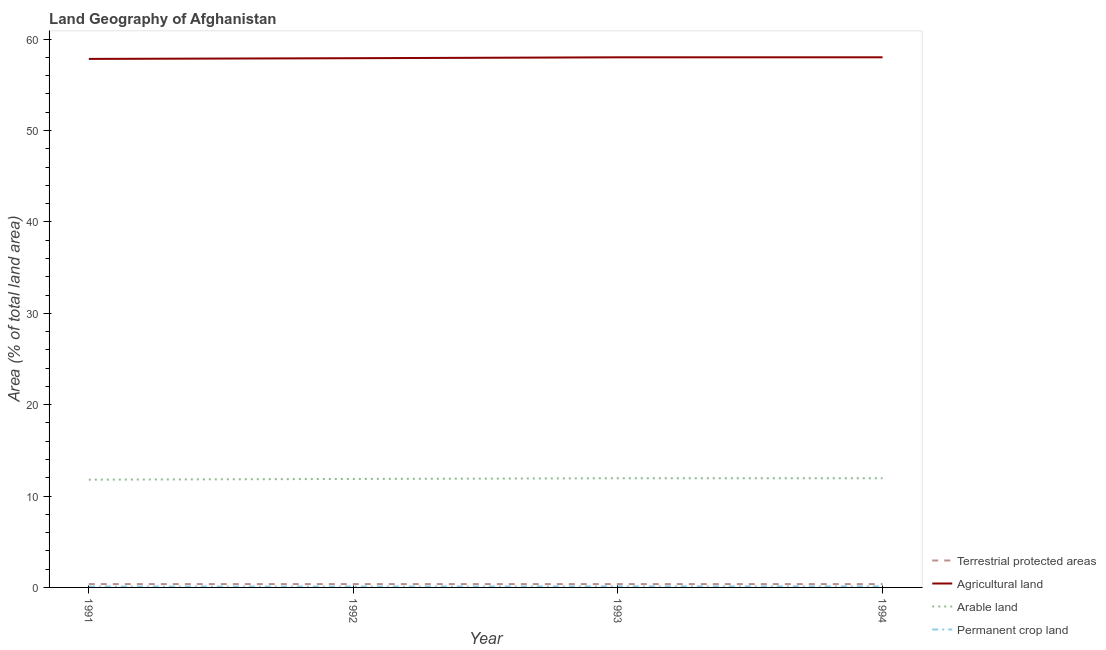How many different coloured lines are there?
Give a very brief answer. 4. Is the number of lines equal to the number of legend labels?
Offer a very short reply. Yes. What is the percentage of area under arable land in 1993?
Your answer should be compact. 11.95. Across all years, what is the maximum percentage of land under terrestrial protection?
Your response must be concise. 0.37. Across all years, what is the minimum percentage of area under arable land?
Offer a very short reply. 11.79. In which year was the percentage of area under permanent crop land minimum?
Provide a short and direct response. 1991. What is the total percentage of land under terrestrial protection in the graph?
Your response must be concise. 1.47. What is the difference between the percentage of land under terrestrial protection in 1993 and that in 1994?
Provide a short and direct response. 0. What is the difference between the percentage of area under arable land in 1992 and the percentage of area under agricultural land in 1993?
Keep it short and to the point. -46.14. What is the average percentage of land under terrestrial protection per year?
Offer a terse response. 0.37. In the year 1994, what is the difference between the percentage of area under arable land and percentage of area under permanent crop land?
Your response must be concise. 11.83. In how many years, is the percentage of area under permanent crop land greater than 50 %?
Make the answer very short. 0. What is the ratio of the percentage of area under arable land in 1992 to that in 1993?
Offer a terse response. 0.99. Is the difference between the percentage of area under agricultural land in 1992 and 1994 greater than the difference between the percentage of land under terrestrial protection in 1992 and 1994?
Give a very brief answer. No. What is the difference between the highest and the second highest percentage of area under arable land?
Your response must be concise. 0. What is the difference between the highest and the lowest percentage of area under agricultural land?
Give a very brief answer. 0.18. In how many years, is the percentage of area under agricultural land greater than the average percentage of area under agricultural land taken over all years?
Ensure brevity in your answer.  2. Is it the case that in every year, the sum of the percentage of land under terrestrial protection and percentage of area under agricultural land is greater than the percentage of area under arable land?
Provide a succinct answer. Yes. How many years are there in the graph?
Your response must be concise. 4. What is the difference between two consecutive major ticks on the Y-axis?
Ensure brevity in your answer.  10. Are the values on the major ticks of Y-axis written in scientific E-notation?
Ensure brevity in your answer.  No. Does the graph contain any zero values?
Provide a short and direct response. No. Does the graph contain grids?
Offer a very short reply. No. Where does the legend appear in the graph?
Your answer should be very brief. Bottom right. How many legend labels are there?
Keep it short and to the point. 4. What is the title of the graph?
Your response must be concise. Land Geography of Afghanistan. What is the label or title of the X-axis?
Keep it short and to the point. Year. What is the label or title of the Y-axis?
Keep it short and to the point. Area (% of total land area). What is the Area (% of total land area) in Terrestrial protected areas in 1991?
Provide a short and direct response. 0.37. What is the Area (% of total land area) in Agricultural land in 1991?
Your answer should be compact. 57.84. What is the Area (% of total land area) of Arable land in 1991?
Your response must be concise. 11.79. What is the Area (% of total land area) in Permanent crop land in 1991?
Make the answer very short. 0.09. What is the Area (% of total land area) of Terrestrial protected areas in 1992?
Provide a short and direct response. 0.37. What is the Area (% of total land area) in Agricultural land in 1992?
Provide a succinct answer. 57.91. What is the Area (% of total land area) of Arable land in 1992?
Ensure brevity in your answer.  11.87. What is the Area (% of total land area) in Permanent crop land in 1992?
Offer a terse response. 0.09. What is the Area (% of total land area) of Terrestrial protected areas in 1993?
Ensure brevity in your answer.  0.37. What is the Area (% of total land area) of Agricultural land in 1993?
Make the answer very short. 58.01. What is the Area (% of total land area) of Arable land in 1993?
Offer a terse response. 11.95. What is the Area (% of total land area) of Permanent crop land in 1993?
Your answer should be compact. 0.11. What is the Area (% of total land area) of Terrestrial protected areas in 1994?
Offer a terse response. 0.37. What is the Area (% of total land area) of Agricultural land in 1994?
Your answer should be compact. 58.01. What is the Area (% of total land area) in Arable land in 1994?
Give a very brief answer. 11.95. What is the Area (% of total land area) in Permanent crop land in 1994?
Keep it short and to the point. 0.11. Across all years, what is the maximum Area (% of total land area) of Terrestrial protected areas?
Offer a very short reply. 0.37. Across all years, what is the maximum Area (% of total land area) in Agricultural land?
Offer a very short reply. 58.01. Across all years, what is the maximum Area (% of total land area) in Arable land?
Offer a terse response. 11.95. Across all years, what is the maximum Area (% of total land area) in Permanent crop land?
Offer a terse response. 0.11. Across all years, what is the minimum Area (% of total land area) in Terrestrial protected areas?
Ensure brevity in your answer.  0.37. Across all years, what is the minimum Area (% of total land area) in Agricultural land?
Offer a terse response. 57.84. Across all years, what is the minimum Area (% of total land area) in Arable land?
Ensure brevity in your answer.  11.79. Across all years, what is the minimum Area (% of total land area) in Permanent crop land?
Offer a terse response. 0.09. What is the total Area (% of total land area) of Terrestrial protected areas in the graph?
Provide a succinct answer. 1.47. What is the total Area (% of total land area) of Agricultural land in the graph?
Keep it short and to the point. 231.78. What is the total Area (% of total land area) in Arable land in the graph?
Your answer should be very brief. 47.56. What is the total Area (% of total land area) of Permanent crop land in the graph?
Offer a very short reply. 0.41. What is the difference between the Area (% of total land area) of Agricultural land in 1991 and that in 1992?
Ensure brevity in your answer.  -0.08. What is the difference between the Area (% of total land area) of Arable land in 1991 and that in 1992?
Offer a very short reply. -0.08. What is the difference between the Area (% of total land area) of Permanent crop land in 1991 and that in 1992?
Give a very brief answer. 0. What is the difference between the Area (% of total land area) in Terrestrial protected areas in 1991 and that in 1993?
Give a very brief answer. 0. What is the difference between the Area (% of total land area) of Agricultural land in 1991 and that in 1993?
Ensure brevity in your answer.  -0.17. What is the difference between the Area (% of total land area) in Arable land in 1991 and that in 1993?
Provide a succinct answer. -0.15. What is the difference between the Area (% of total land area) in Permanent crop land in 1991 and that in 1993?
Offer a very short reply. -0.02. What is the difference between the Area (% of total land area) of Terrestrial protected areas in 1991 and that in 1994?
Provide a short and direct response. 0. What is the difference between the Area (% of total land area) in Agricultural land in 1991 and that in 1994?
Your answer should be compact. -0.18. What is the difference between the Area (% of total land area) in Arable land in 1991 and that in 1994?
Offer a terse response. -0.15. What is the difference between the Area (% of total land area) in Permanent crop land in 1991 and that in 1994?
Your answer should be very brief. -0.02. What is the difference between the Area (% of total land area) in Agricultural land in 1992 and that in 1993?
Provide a succinct answer. -0.1. What is the difference between the Area (% of total land area) of Arable land in 1992 and that in 1993?
Your response must be concise. -0.08. What is the difference between the Area (% of total land area) of Permanent crop land in 1992 and that in 1993?
Provide a succinct answer. -0.02. What is the difference between the Area (% of total land area) in Agricultural land in 1992 and that in 1994?
Provide a succinct answer. -0.1. What is the difference between the Area (% of total land area) in Arable land in 1992 and that in 1994?
Provide a succinct answer. -0.08. What is the difference between the Area (% of total land area) of Permanent crop land in 1992 and that in 1994?
Make the answer very short. -0.02. What is the difference between the Area (% of total land area) in Terrestrial protected areas in 1993 and that in 1994?
Your answer should be compact. 0. What is the difference between the Area (% of total land area) in Agricultural land in 1993 and that in 1994?
Provide a succinct answer. -0. What is the difference between the Area (% of total land area) in Arable land in 1993 and that in 1994?
Offer a terse response. 0. What is the difference between the Area (% of total land area) in Permanent crop land in 1993 and that in 1994?
Offer a terse response. -0. What is the difference between the Area (% of total land area) of Terrestrial protected areas in 1991 and the Area (% of total land area) of Agricultural land in 1992?
Provide a short and direct response. -57.55. What is the difference between the Area (% of total land area) of Terrestrial protected areas in 1991 and the Area (% of total land area) of Arable land in 1992?
Keep it short and to the point. -11.5. What is the difference between the Area (% of total land area) of Terrestrial protected areas in 1991 and the Area (% of total land area) of Permanent crop land in 1992?
Offer a very short reply. 0.28. What is the difference between the Area (% of total land area) in Agricultural land in 1991 and the Area (% of total land area) in Arable land in 1992?
Give a very brief answer. 45.97. What is the difference between the Area (% of total land area) in Agricultural land in 1991 and the Area (% of total land area) in Permanent crop land in 1992?
Your answer should be very brief. 57.75. What is the difference between the Area (% of total land area) of Arable land in 1991 and the Area (% of total land area) of Permanent crop land in 1992?
Offer a very short reply. 11.7. What is the difference between the Area (% of total land area) in Terrestrial protected areas in 1991 and the Area (% of total land area) in Agricultural land in 1993?
Provide a succinct answer. -57.64. What is the difference between the Area (% of total land area) in Terrestrial protected areas in 1991 and the Area (% of total land area) in Arable land in 1993?
Offer a very short reply. -11.58. What is the difference between the Area (% of total land area) in Terrestrial protected areas in 1991 and the Area (% of total land area) in Permanent crop land in 1993?
Make the answer very short. 0.26. What is the difference between the Area (% of total land area) in Agricultural land in 1991 and the Area (% of total land area) in Arable land in 1993?
Give a very brief answer. 45.89. What is the difference between the Area (% of total land area) of Agricultural land in 1991 and the Area (% of total land area) of Permanent crop land in 1993?
Keep it short and to the point. 57.73. What is the difference between the Area (% of total land area) in Arable land in 1991 and the Area (% of total land area) in Permanent crop land in 1993?
Provide a succinct answer. 11.68. What is the difference between the Area (% of total land area) in Terrestrial protected areas in 1991 and the Area (% of total land area) in Agricultural land in 1994?
Give a very brief answer. -57.65. What is the difference between the Area (% of total land area) in Terrestrial protected areas in 1991 and the Area (% of total land area) in Arable land in 1994?
Provide a succinct answer. -11.58. What is the difference between the Area (% of total land area) of Terrestrial protected areas in 1991 and the Area (% of total land area) of Permanent crop land in 1994?
Ensure brevity in your answer.  0.25. What is the difference between the Area (% of total land area) of Agricultural land in 1991 and the Area (% of total land area) of Arable land in 1994?
Give a very brief answer. 45.89. What is the difference between the Area (% of total land area) in Agricultural land in 1991 and the Area (% of total land area) in Permanent crop land in 1994?
Your answer should be very brief. 57.72. What is the difference between the Area (% of total land area) of Arable land in 1991 and the Area (% of total land area) of Permanent crop land in 1994?
Offer a terse response. 11.68. What is the difference between the Area (% of total land area) of Terrestrial protected areas in 1992 and the Area (% of total land area) of Agricultural land in 1993?
Offer a very short reply. -57.64. What is the difference between the Area (% of total land area) in Terrestrial protected areas in 1992 and the Area (% of total land area) in Arable land in 1993?
Your response must be concise. -11.58. What is the difference between the Area (% of total land area) in Terrestrial protected areas in 1992 and the Area (% of total land area) in Permanent crop land in 1993?
Keep it short and to the point. 0.26. What is the difference between the Area (% of total land area) in Agricultural land in 1992 and the Area (% of total land area) in Arable land in 1993?
Your response must be concise. 45.97. What is the difference between the Area (% of total land area) of Agricultural land in 1992 and the Area (% of total land area) of Permanent crop land in 1993?
Your response must be concise. 57.8. What is the difference between the Area (% of total land area) of Arable land in 1992 and the Area (% of total land area) of Permanent crop land in 1993?
Provide a succinct answer. 11.76. What is the difference between the Area (% of total land area) in Terrestrial protected areas in 1992 and the Area (% of total land area) in Agricultural land in 1994?
Ensure brevity in your answer.  -57.65. What is the difference between the Area (% of total land area) of Terrestrial protected areas in 1992 and the Area (% of total land area) of Arable land in 1994?
Make the answer very short. -11.58. What is the difference between the Area (% of total land area) in Terrestrial protected areas in 1992 and the Area (% of total land area) in Permanent crop land in 1994?
Provide a succinct answer. 0.25. What is the difference between the Area (% of total land area) in Agricultural land in 1992 and the Area (% of total land area) in Arable land in 1994?
Ensure brevity in your answer.  45.97. What is the difference between the Area (% of total land area) in Agricultural land in 1992 and the Area (% of total land area) in Permanent crop land in 1994?
Provide a short and direct response. 57.8. What is the difference between the Area (% of total land area) in Arable land in 1992 and the Area (% of total land area) in Permanent crop land in 1994?
Your answer should be very brief. 11.76. What is the difference between the Area (% of total land area) of Terrestrial protected areas in 1993 and the Area (% of total land area) of Agricultural land in 1994?
Ensure brevity in your answer.  -57.65. What is the difference between the Area (% of total land area) of Terrestrial protected areas in 1993 and the Area (% of total land area) of Arable land in 1994?
Offer a very short reply. -11.58. What is the difference between the Area (% of total land area) of Terrestrial protected areas in 1993 and the Area (% of total land area) of Permanent crop land in 1994?
Give a very brief answer. 0.25. What is the difference between the Area (% of total land area) of Agricultural land in 1993 and the Area (% of total land area) of Arable land in 1994?
Provide a succinct answer. 46.06. What is the difference between the Area (% of total land area) in Agricultural land in 1993 and the Area (% of total land area) in Permanent crop land in 1994?
Provide a short and direct response. 57.9. What is the difference between the Area (% of total land area) of Arable land in 1993 and the Area (% of total land area) of Permanent crop land in 1994?
Your answer should be very brief. 11.83. What is the average Area (% of total land area) in Terrestrial protected areas per year?
Offer a terse response. 0.37. What is the average Area (% of total land area) in Agricultural land per year?
Ensure brevity in your answer.  57.94. What is the average Area (% of total land area) of Arable land per year?
Offer a very short reply. 11.89. What is the average Area (% of total land area) of Permanent crop land per year?
Your response must be concise. 0.1. In the year 1991, what is the difference between the Area (% of total land area) of Terrestrial protected areas and Area (% of total land area) of Agricultural land?
Your response must be concise. -57.47. In the year 1991, what is the difference between the Area (% of total land area) of Terrestrial protected areas and Area (% of total land area) of Arable land?
Ensure brevity in your answer.  -11.43. In the year 1991, what is the difference between the Area (% of total land area) of Terrestrial protected areas and Area (% of total land area) of Permanent crop land?
Your response must be concise. 0.28. In the year 1991, what is the difference between the Area (% of total land area) of Agricultural land and Area (% of total land area) of Arable land?
Offer a terse response. 46.04. In the year 1991, what is the difference between the Area (% of total land area) of Agricultural land and Area (% of total land area) of Permanent crop land?
Keep it short and to the point. 57.75. In the year 1991, what is the difference between the Area (% of total land area) in Arable land and Area (% of total land area) in Permanent crop land?
Your response must be concise. 11.7. In the year 1992, what is the difference between the Area (% of total land area) in Terrestrial protected areas and Area (% of total land area) in Agricultural land?
Offer a terse response. -57.55. In the year 1992, what is the difference between the Area (% of total land area) of Terrestrial protected areas and Area (% of total land area) of Arable land?
Ensure brevity in your answer.  -11.5. In the year 1992, what is the difference between the Area (% of total land area) in Terrestrial protected areas and Area (% of total land area) in Permanent crop land?
Your response must be concise. 0.28. In the year 1992, what is the difference between the Area (% of total land area) in Agricultural land and Area (% of total land area) in Arable land?
Your answer should be compact. 46.04. In the year 1992, what is the difference between the Area (% of total land area) in Agricultural land and Area (% of total land area) in Permanent crop land?
Keep it short and to the point. 57.82. In the year 1992, what is the difference between the Area (% of total land area) in Arable land and Area (% of total land area) in Permanent crop land?
Keep it short and to the point. 11.78. In the year 1993, what is the difference between the Area (% of total land area) in Terrestrial protected areas and Area (% of total land area) in Agricultural land?
Your answer should be compact. -57.64. In the year 1993, what is the difference between the Area (% of total land area) of Terrestrial protected areas and Area (% of total land area) of Arable land?
Offer a terse response. -11.58. In the year 1993, what is the difference between the Area (% of total land area) in Terrestrial protected areas and Area (% of total land area) in Permanent crop land?
Give a very brief answer. 0.26. In the year 1993, what is the difference between the Area (% of total land area) of Agricultural land and Area (% of total land area) of Arable land?
Provide a short and direct response. 46.06. In the year 1993, what is the difference between the Area (% of total land area) in Agricultural land and Area (% of total land area) in Permanent crop land?
Your answer should be compact. 57.9. In the year 1993, what is the difference between the Area (% of total land area) of Arable land and Area (% of total land area) of Permanent crop land?
Offer a terse response. 11.84. In the year 1994, what is the difference between the Area (% of total land area) in Terrestrial protected areas and Area (% of total land area) in Agricultural land?
Provide a short and direct response. -57.65. In the year 1994, what is the difference between the Area (% of total land area) in Terrestrial protected areas and Area (% of total land area) in Arable land?
Offer a very short reply. -11.58. In the year 1994, what is the difference between the Area (% of total land area) of Terrestrial protected areas and Area (% of total land area) of Permanent crop land?
Make the answer very short. 0.25. In the year 1994, what is the difference between the Area (% of total land area) of Agricultural land and Area (% of total land area) of Arable land?
Your answer should be very brief. 46.07. In the year 1994, what is the difference between the Area (% of total land area) of Agricultural land and Area (% of total land area) of Permanent crop land?
Offer a terse response. 57.9. In the year 1994, what is the difference between the Area (% of total land area) of Arable land and Area (% of total land area) of Permanent crop land?
Provide a short and direct response. 11.83. What is the ratio of the Area (% of total land area) in Agricultural land in 1991 to that in 1992?
Provide a succinct answer. 1. What is the ratio of the Area (% of total land area) of Arable land in 1991 to that in 1992?
Ensure brevity in your answer.  0.99. What is the ratio of the Area (% of total land area) of Terrestrial protected areas in 1991 to that in 1993?
Keep it short and to the point. 1. What is the ratio of the Area (% of total land area) of Agricultural land in 1991 to that in 1993?
Make the answer very short. 1. What is the ratio of the Area (% of total land area) in Arable land in 1991 to that in 1993?
Ensure brevity in your answer.  0.99. What is the ratio of the Area (% of total land area) of Permanent crop land in 1991 to that in 1993?
Keep it short and to the point. 0.82. What is the ratio of the Area (% of total land area) of Arable land in 1991 to that in 1994?
Give a very brief answer. 0.99. What is the ratio of the Area (% of total land area) of Permanent crop land in 1991 to that in 1994?
Keep it short and to the point. 0.8. What is the ratio of the Area (% of total land area) of Agricultural land in 1992 to that in 1993?
Offer a very short reply. 1. What is the ratio of the Area (% of total land area) in Permanent crop land in 1992 to that in 1993?
Provide a succinct answer. 0.82. What is the ratio of the Area (% of total land area) in Terrestrial protected areas in 1992 to that in 1994?
Your response must be concise. 1. What is the ratio of the Area (% of total land area) of Arable land in 1992 to that in 1994?
Your answer should be compact. 0.99. What is the ratio of the Area (% of total land area) in Terrestrial protected areas in 1993 to that in 1994?
Give a very brief answer. 1. What is the ratio of the Area (% of total land area) in Agricultural land in 1993 to that in 1994?
Your answer should be very brief. 1. What is the ratio of the Area (% of total land area) in Permanent crop land in 1993 to that in 1994?
Ensure brevity in your answer.  0.97. What is the difference between the highest and the second highest Area (% of total land area) in Agricultural land?
Keep it short and to the point. 0. What is the difference between the highest and the second highest Area (% of total land area) of Permanent crop land?
Your response must be concise. 0. What is the difference between the highest and the lowest Area (% of total land area) in Terrestrial protected areas?
Your answer should be very brief. 0. What is the difference between the highest and the lowest Area (% of total land area) of Agricultural land?
Provide a short and direct response. 0.18. What is the difference between the highest and the lowest Area (% of total land area) in Arable land?
Offer a very short reply. 0.15. What is the difference between the highest and the lowest Area (% of total land area) of Permanent crop land?
Provide a succinct answer. 0.02. 